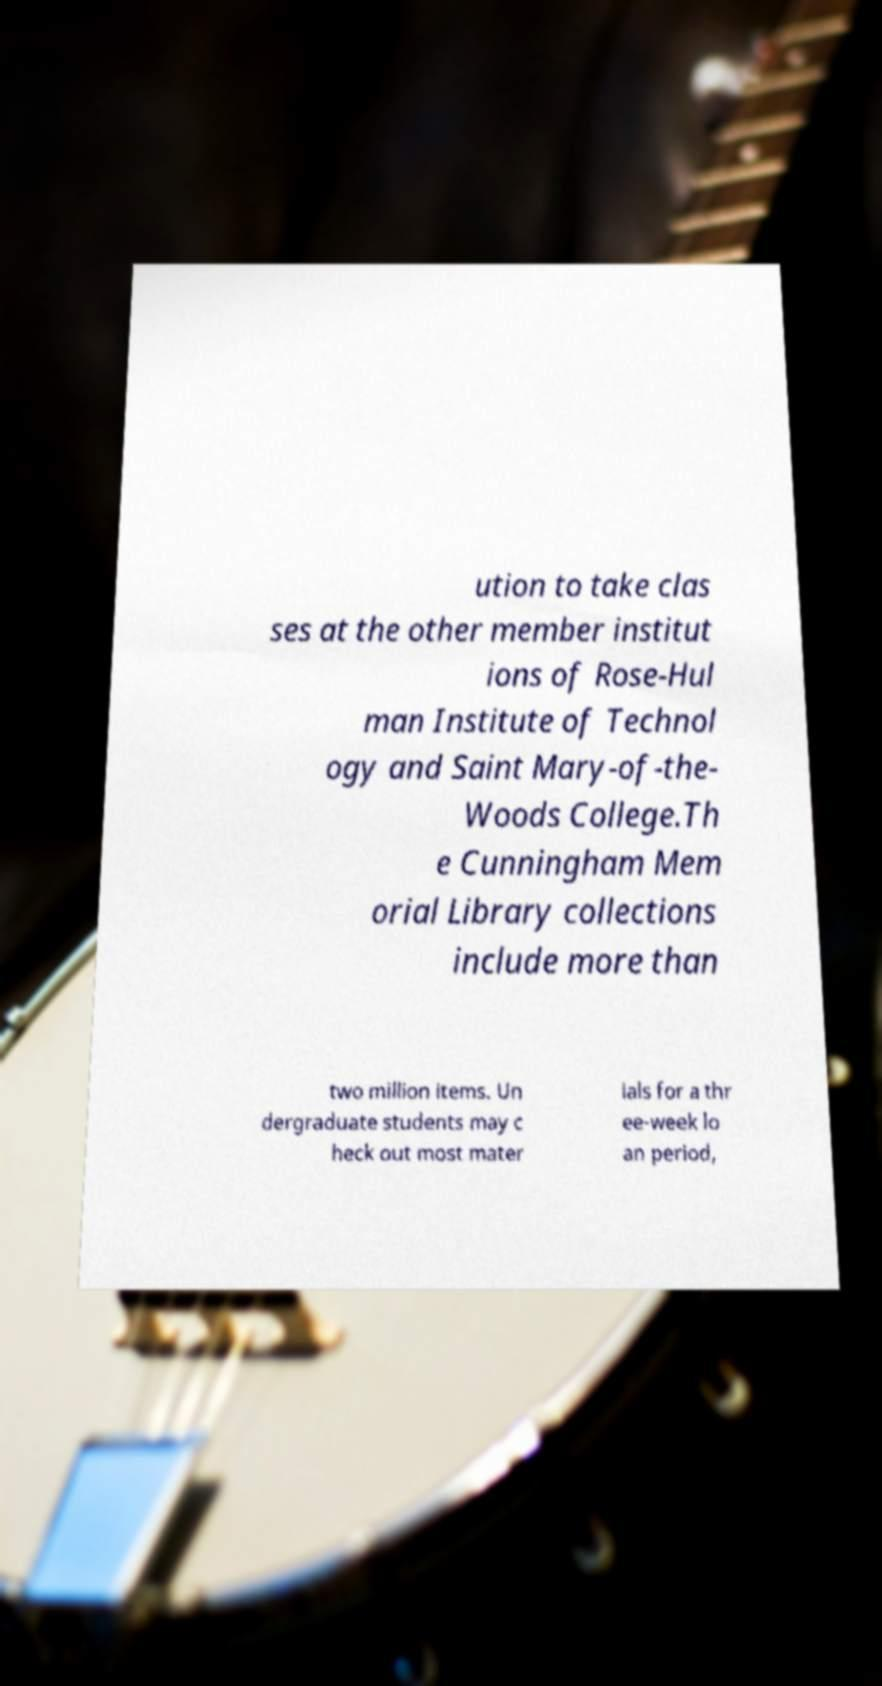Could you assist in decoding the text presented in this image and type it out clearly? ution to take clas ses at the other member institut ions of Rose-Hul man Institute of Technol ogy and Saint Mary-of-the- Woods College.Th e Cunningham Mem orial Library collections include more than two million items. Un dergraduate students may c heck out most mater ials for a thr ee-week lo an period, 